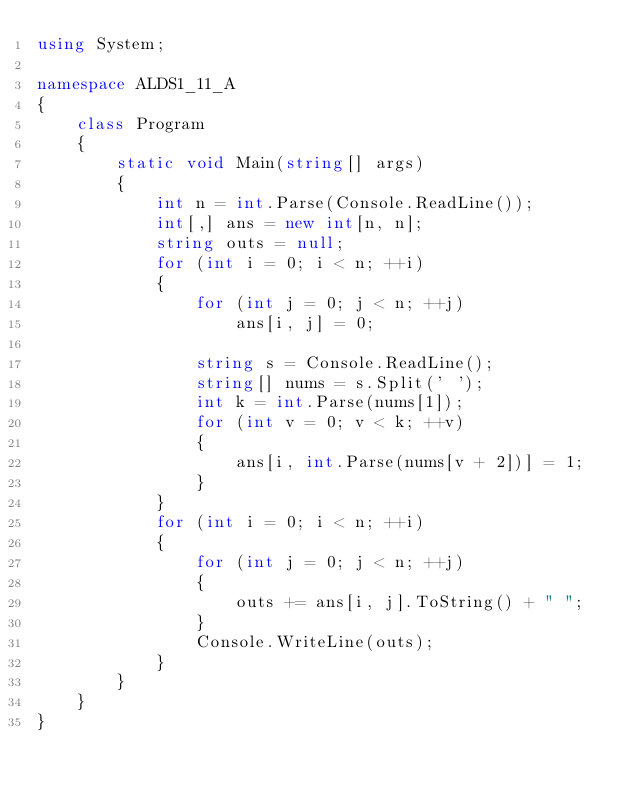<code> <loc_0><loc_0><loc_500><loc_500><_C#_>using System;

namespace ALDS1_11_A
{
    class Program
    {
        static void Main(string[] args)
        {
            int n = int.Parse(Console.ReadLine());
            int[,] ans = new int[n, n];
            string outs = null;
            for (int i = 0; i < n; ++i) 
            {
                for (int j = 0; j < n; ++j) 
                    ans[i, j] = 0;

                string s = Console.ReadLine();
                string[] nums = s.Split(' ');
                int k = int.Parse(nums[1]);
                for (int v = 0; v < k; ++v) 
                {
                    ans[i, int.Parse(nums[v + 2])] = 1;
                }
            }
            for (int i = 0; i < n; ++i) 
            {
                for (int j = 0; j < n; ++j)
                {
                    outs += ans[i, j].ToString() + " ";
                }
                Console.WriteLine(outs);
            }
        }
    }
}</code> 